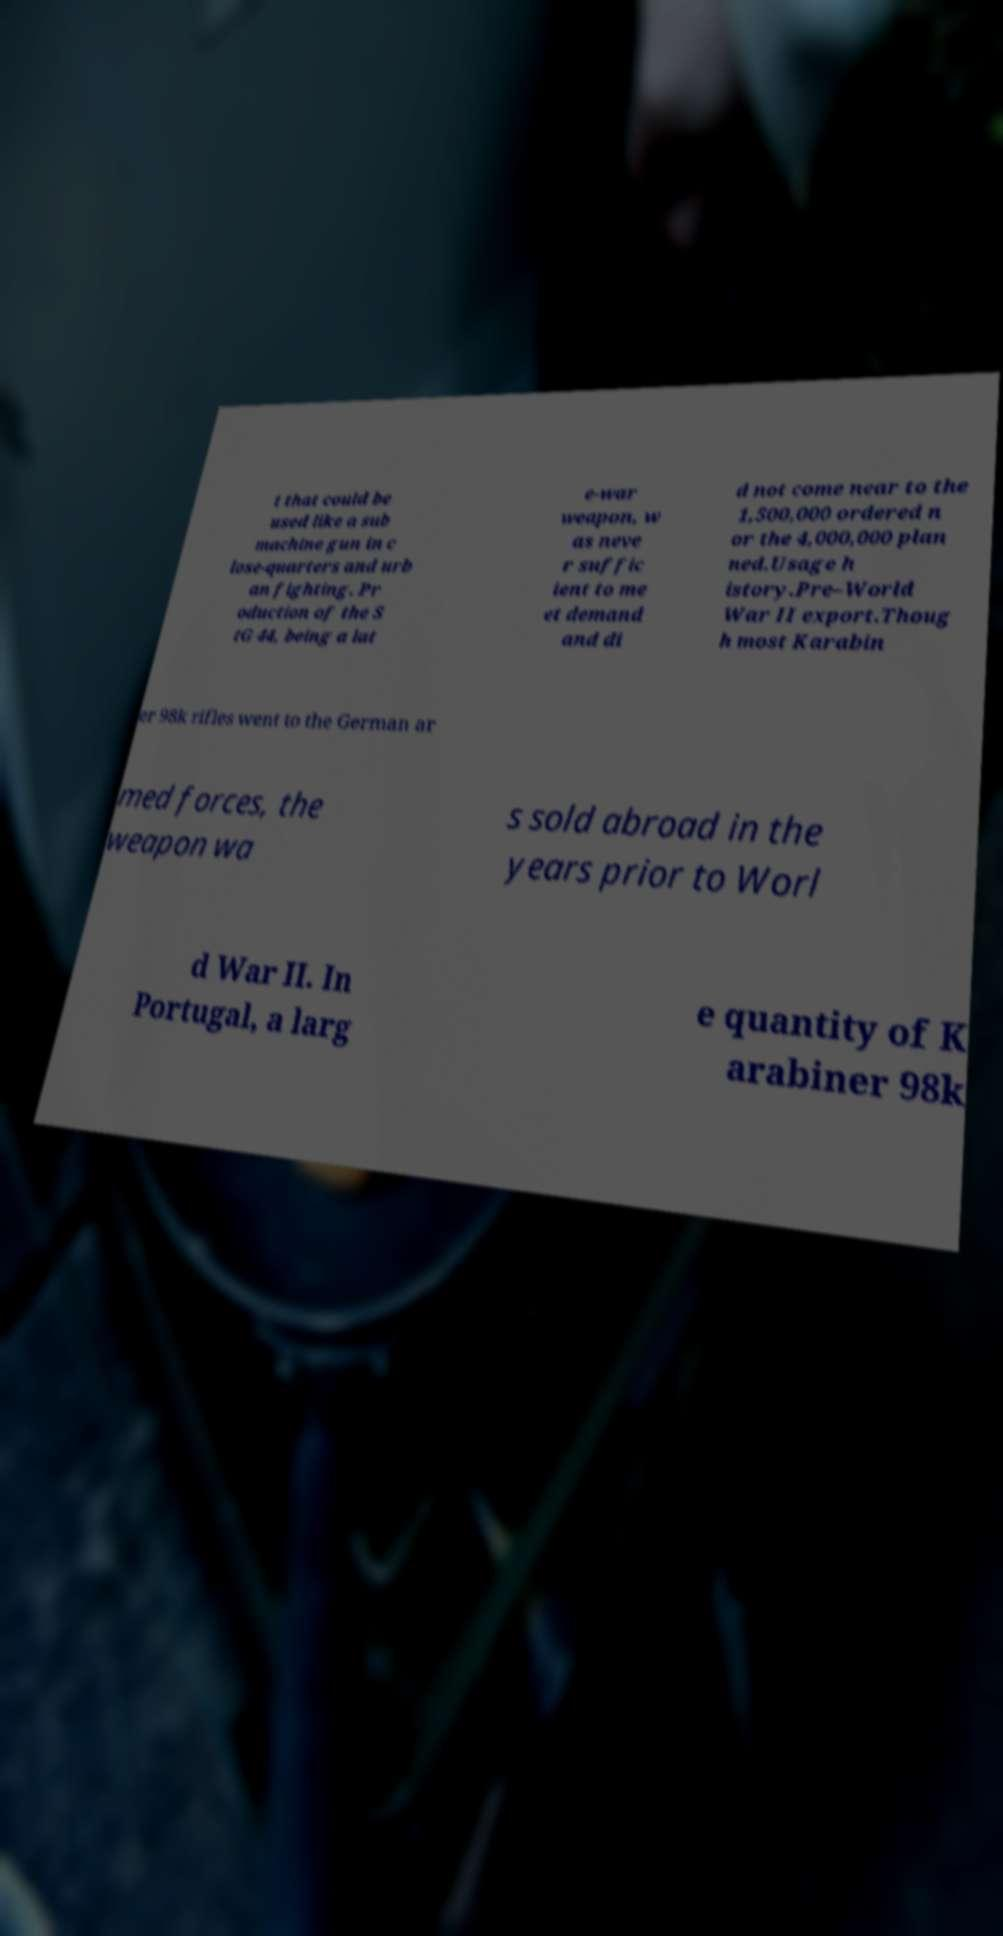What messages or text are displayed in this image? I need them in a readable, typed format. t that could be used like a sub machine gun in c lose-quarters and urb an fighting. Pr oduction of the S tG 44, being a lat e-war weapon, w as neve r suffic ient to me et demand and di d not come near to the 1,500,000 ordered n or the 4,000,000 plan ned.Usage h istory.Pre–World War II export.Thoug h most Karabin er 98k rifles went to the German ar med forces, the weapon wa s sold abroad in the years prior to Worl d War II. In Portugal, a larg e quantity of K arabiner 98k 